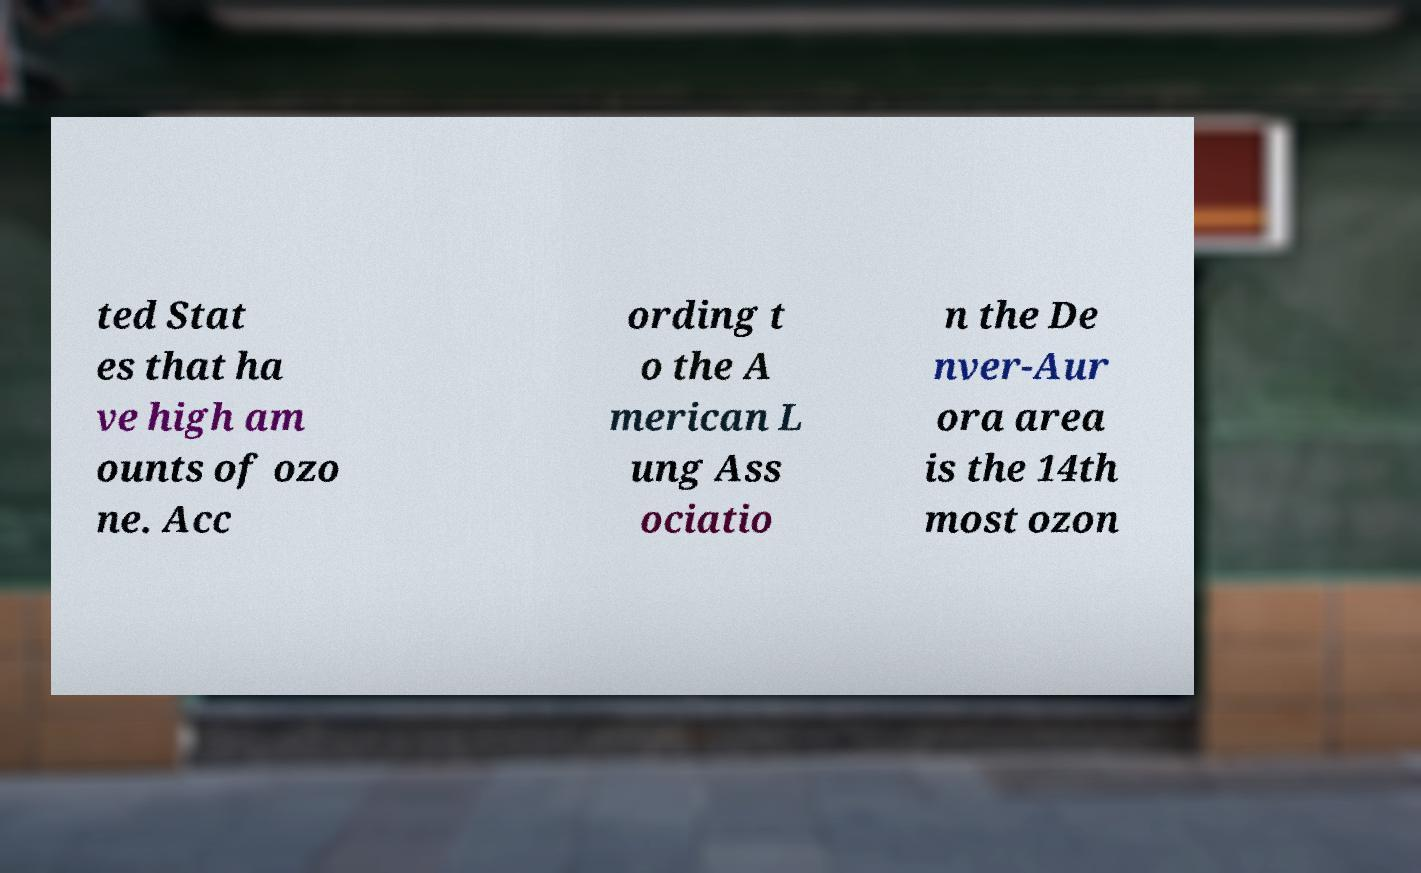Please identify and transcribe the text found in this image. ted Stat es that ha ve high am ounts of ozo ne. Acc ording t o the A merican L ung Ass ociatio n the De nver-Aur ora area is the 14th most ozon 